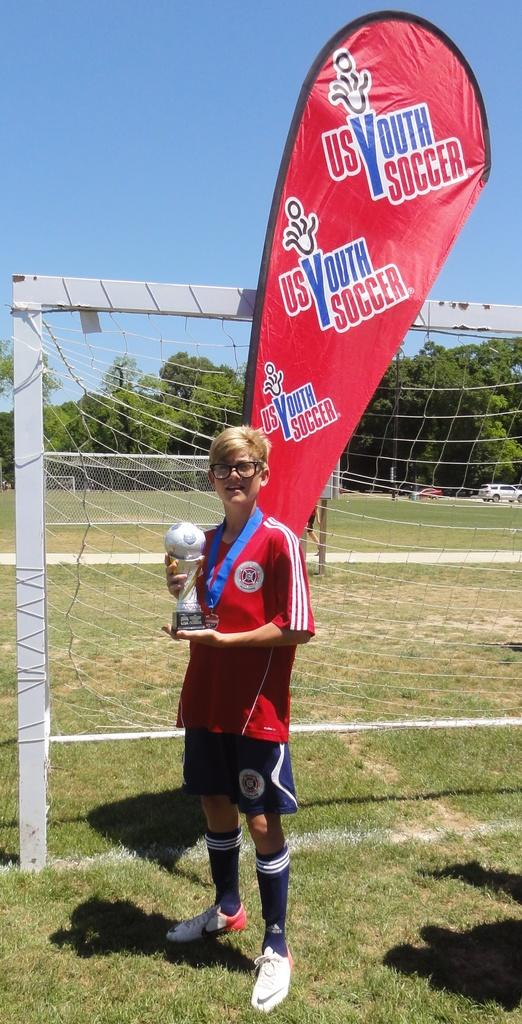<image>
Share a concise interpretation of the image provided. A young person holds a trophy below a US Youth Soccer flag. 